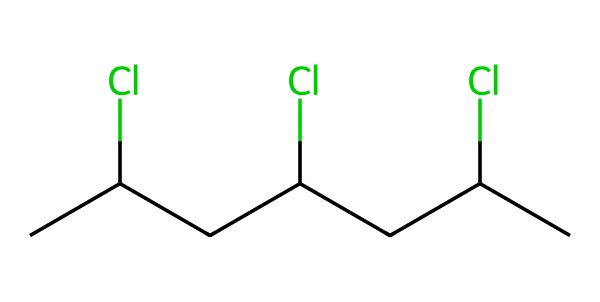What is the main functional group in the chemical structure of PVC? The main functional groups in the structure of PVC are the chlorine substituents attached to the carbon backbone. In the SMILES representation, the 'Cl' indicates the presence of chlorine atoms contributing to PVC's unique properties.
Answer: chlorine How many carbon atoms are present in the chemical structure? By analyzing the SMILES representation, you can count the carbon atoms represented by 'C'. In this case, there are 6 carbon atoms evident in the sequence of the structure.
Answer: 6 What type of polymer is represented by this chemical structure? The presence of repeating units of vinyl chloride indicates that this polymer is a type of addition polymer, specifically a vinyl polymer due to the source of its monomers.
Answer: addition polymer What is the significance of the chlorine atoms in the PVC structure? The chlorine atoms in PVC influence its properties such as chemical resistance and flammability. This results from the presence of halogen elements which enhance these characteristics.
Answer: enhance properties How many chlorine atoms are there in the polyvinyl chloride structure? Counting the 'Cl' symbols in the SMILES notation, we see there are three instances of 'Cl', indicating that there are three chlorine atoms in the structure.
Answer: 3 What kind of bonds are present in the polymer structure? The chemical structure of PVC contains covalent bonds between carbon and chlorine atoms as well as between the carbon atoms themselves, typical of organic polymers.
Answer: covalent bonds 